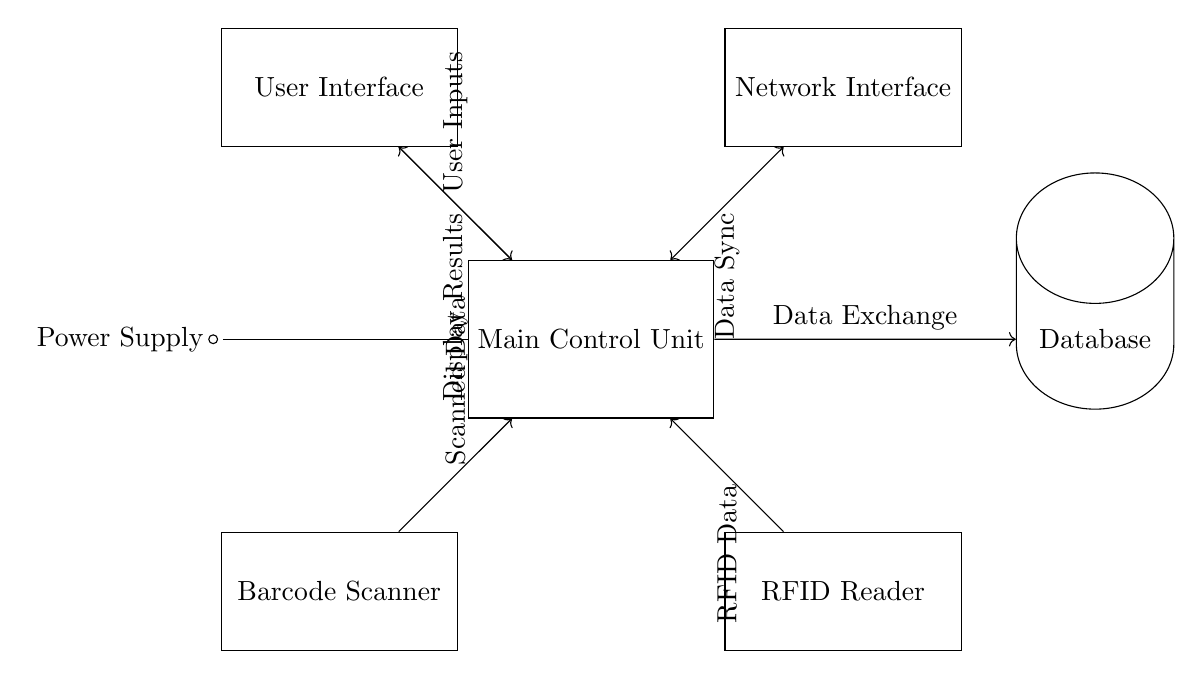What is the main function of the Main Control Unit? The Main Control Unit processes all user inputs and manages data exchange with the database, acting as the central brain of the automated library catalog system.
Answer: processing inputs What component interfaces with users? The User Interface allows users to interact with the library catalog system, entering data and receiving feedback, which is clearly indicated in the circuit.
Answer: User Interface How does the power supply connect to the circuit? The power supply, represented as a battery symbol, connects directly to the Main Control Unit, providing necessary power for circuit operation.
Answer: Main Control Unit What types of data does the Barcode Scanner provide to the Main Control Unit? The Barcode Scanner transmits the scanned data from physical barcodes to the Main Control Unit for processing, a function clearly labeled in the circuit connections.
Answer: Scanned Data What type of connection exists between the Main Control Unit and the Network Interface? The connection between the Main Control Unit and Network Interface is bidirectional, indicated by a double-headed arrow, allowing data synchronization in both directions.
Answer: Data Sync What component receives input from the RFID Reader? The RFID Reader sends its data directly to the Main Control Unit, indicating the flow of RFID-based information within the system.
Answer: Main Control Unit What is the purpose of the Database in this circuit? The Database stores catalog information and manages data exchange with the Main Control Unit, playing a critical role in data retention and retrieval.
Answer: Data storage 